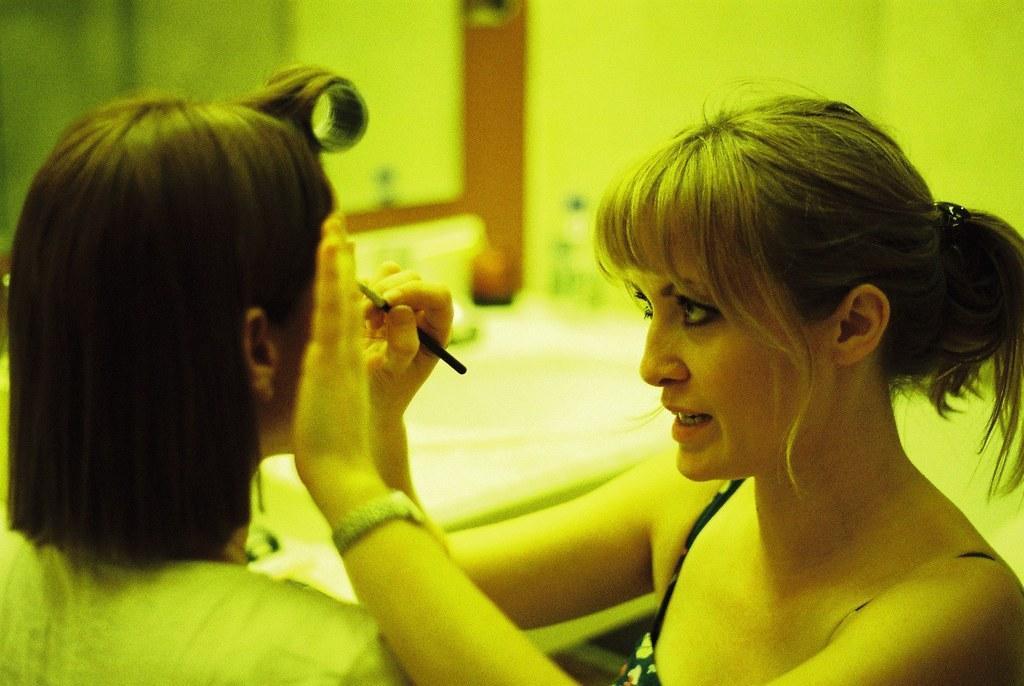Please provide a concise description of this image. In this image I can see on the right side a woman is looking at the left side and also touching another person, at the top it looks like a mirror. 